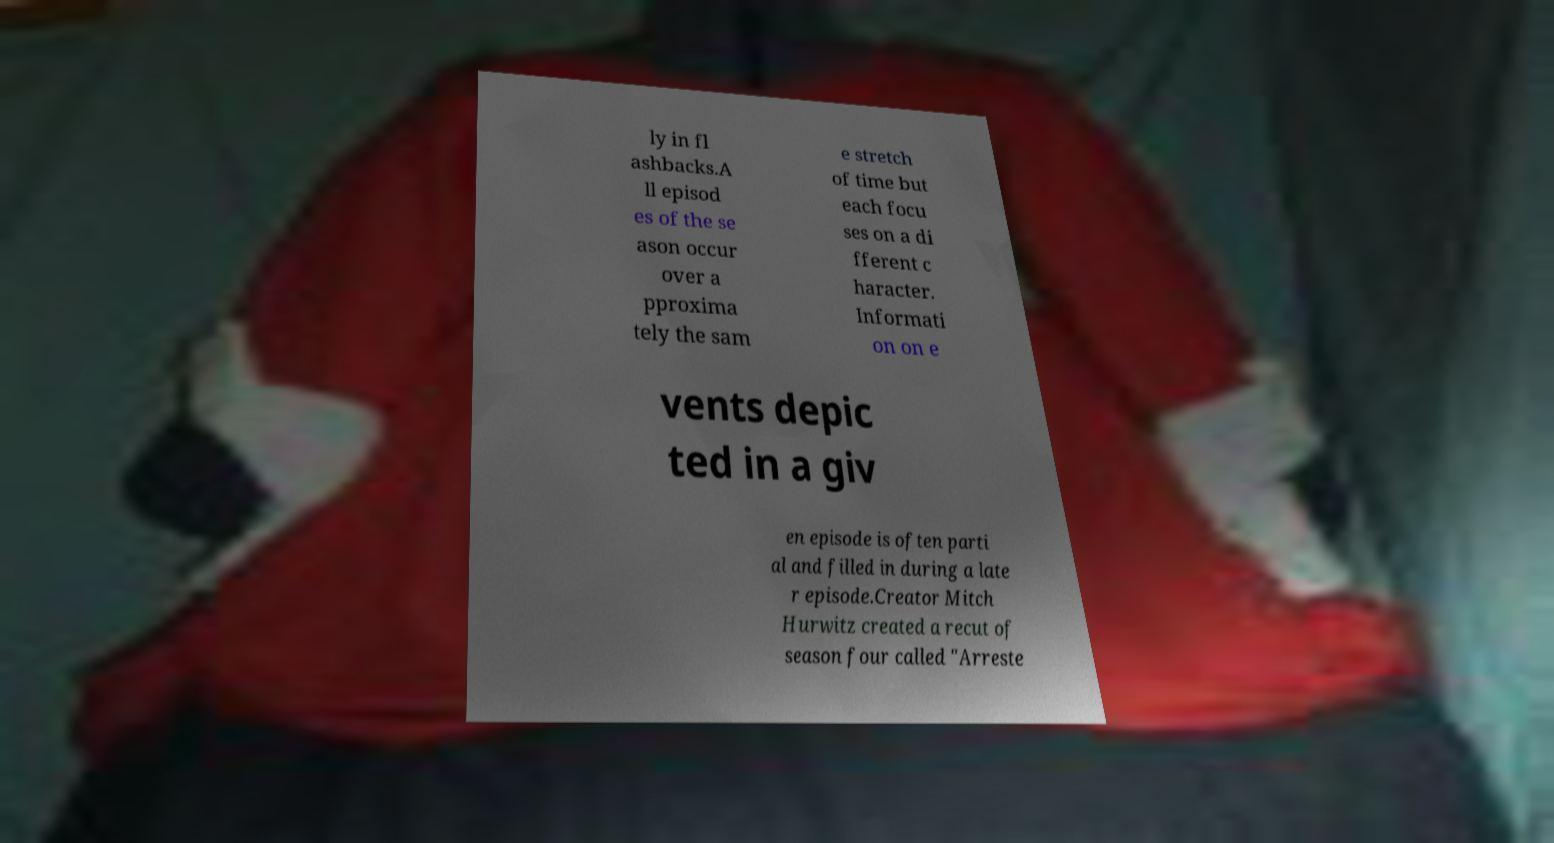For documentation purposes, I need the text within this image transcribed. Could you provide that? ly in fl ashbacks.A ll episod es of the se ason occur over a pproxima tely the sam e stretch of time but each focu ses on a di fferent c haracter. Informati on on e vents depic ted in a giv en episode is often parti al and filled in during a late r episode.Creator Mitch Hurwitz created a recut of season four called "Arreste 